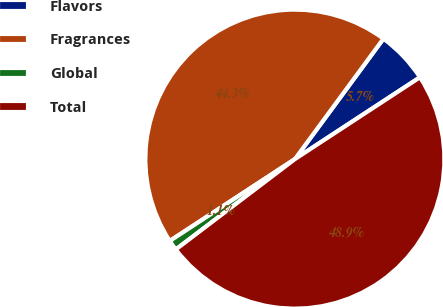Convert chart to OTSL. <chart><loc_0><loc_0><loc_500><loc_500><pie_chart><fcel>Flavors<fcel>Fragrances<fcel>Global<fcel>Total<nl><fcel>5.69%<fcel>44.31%<fcel>1.11%<fcel>48.89%<nl></chart> 